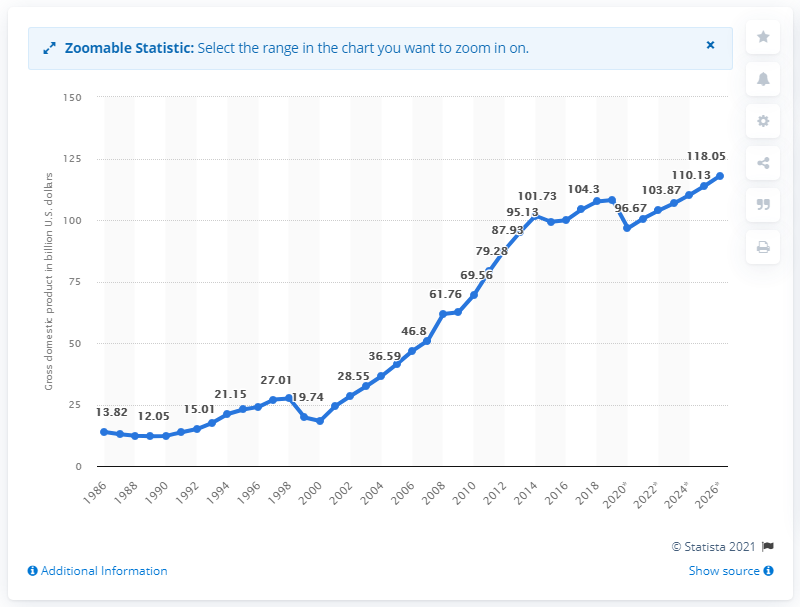Identify some key points in this picture. In 2019, Ecuador's Gross Domestic Product was 108.11. 